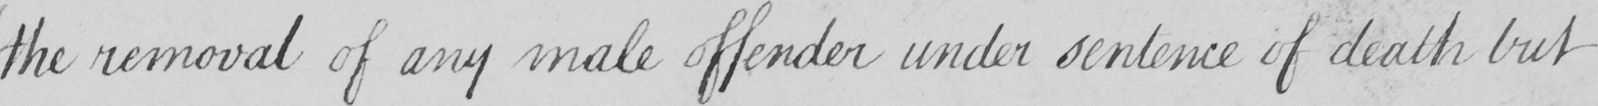Can you read and transcribe this handwriting? the removal of any male offender under sentence of death but 